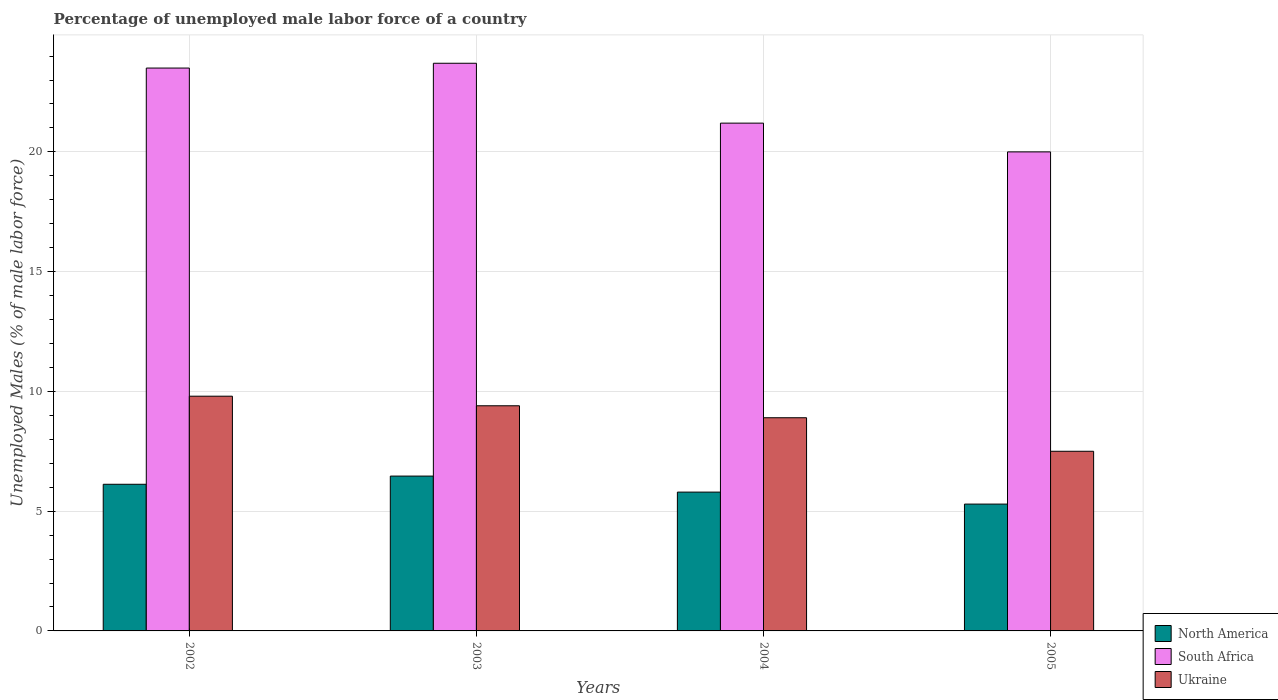How many different coloured bars are there?
Offer a very short reply. 3. How many groups of bars are there?
Keep it short and to the point. 4. What is the label of the 3rd group of bars from the left?
Your response must be concise. 2004. In how many cases, is the number of bars for a given year not equal to the number of legend labels?
Offer a very short reply. 0. What is the percentage of unemployed male labor force in North America in 2002?
Your answer should be compact. 6.12. Across all years, what is the maximum percentage of unemployed male labor force in North America?
Give a very brief answer. 6.46. Across all years, what is the minimum percentage of unemployed male labor force in North America?
Provide a short and direct response. 5.3. In which year was the percentage of unemployed male labor force in North America minimum?
Ensure brevity in your answer.  2005. What is the total percentage of unemployed male labor force in North America in the graph?
Your response must be concise. 23.68. What is the difference between the percentage of unemployed male labor force in North America in 2003 and that in 2004?
Your response must be concise. 0.67. What is the difference between the percentage of unemployed male labor force in South Africa in 2005 and the percentage of unemployed male labor force in North America in 2003?
Offer a terse response. 13.54. What is the average percentage of unemployed male labor force in South Africa per year?
Your answer should be very brief. 22.1. In the year 2002, what is the difference between the percentage of unemployed male labor force in Ukraine and percentage of unemployed male labor force in South Africa?
Your response must be concise. -13.7. What is the ratio of the percentage of unemployed male labor force in North America in 2004 to that in 2005?
Your answer should be compact. 1.09. What is the difference between the highest and the second highest percentage of unemployed male labor force in North America?
Ensure brevity in your answer.  0.34. What is the difference between the highest and the lowest percentage of unemployed male labor force in Ukraine?
Offer a very short reply. 2.3. In how many years, is the percentage of unemployed male labor force in Ukraine greater than the average percentage of unemployed male labor force in Ukraine taken over all years?
Your response must be concise. 2. Is the sum of the percentage of unemployed male labor force in North America in 2003 and 2005 greater than the maximum percentage of unemployed male labor force in South Africa across all years?
Offer a very short reply. No. What does the 2nd bar from the left in 2004 represents?
Ensure brevity in your answer.  South Africa. What does the 1st bar from the right in 2002 represents?
Make the answer very short. Ukraine. How many bars are there?
Offer a very short reply. 12. Are all the bars in the graph horizontal?
Offer a terse response. No. How many years are there in the graph?
Provide a succinct answer. 4. What is the difference between two consecutive major ticks on the Y-axis?
Offer a very short reply. 5. Are the values on the major ticks of Y-axis written in scientific E-notation?
Keep it short and to the point. No. Where does the legend appear in the graph?
Your answer should be compact. Bottom right. How many legend labels are there?
Offer a very short reply. 3. How are the legend labels stacked?
Your response must be concise. Vertical. What is the title of the graph?
Keep it short and to the point. Percentage of unemployed male labor force of a country. Does "Arab World" appear as one of the legend labels in the graph?
Ensure brevity in your answer.  No. What is the label or title of the X-axis?
Give a very brief answer. Years. What is the label or title of the Y-axis?
Give a very brief answer. Unemployed Males (% of male labor force). What is the Unemployed Males (% of male labor force) in North America in 2002?
Provide a short and direct response. 6.12. What is the Unemployed Males (% of male labor force) of Ukraine in 2002?
Offer a terse response. 9.8. What is the Unemployed Males (% of male labor force) of North America in 2003?
Ensure brevity in your answer.  6.46. What is the Unemployed Males (% of male labor force) in South Africa in 2003?
Make the answer very short. 23.7. What is the Unemployed Males (% of male labor force) in Ukraine in 2003?
Ensure brevity in your answer.  9.4. What is the Unemployed Males (% of male labor force) of North America in 2004?
Offer a terse response. 5.8. What is the Unemployed Males (% of male labor force) in South Africa in 2004?
Provide a short and direct response. 21.2. What is the Unemployed Males (% of male labor force) of Ukraine in 2004?
Provide a short and direct response. 8.9. What is the Unemployed Males (% of male labor force) of North America in 2005?
Your response must be concise. 5.3. What is the Unemployed Males (% of male labor force) in Ukraine in 2005?
Ensure brevity in your answer.  7.5. Across all years, what is the maximum Unemployed Males (% of male labor force) in North America?
Make the answer very short. 6.46. Across all years, what is the maximum Unemployed Males (% of male labor force) in South Africa?
Your answer should be very brief. 23.7. Across all years, what is the maximum Unemployed Males (% of male labor force) in Ukraine?
Ensure brevity in your answer.  9.8. Across all years, what is the minimum Unemployed Males (% of male labor force) in North America?
Provide a succinct answer. 5.3. Across all years, what is the minimum Unemployed Males (% of male labor force) of South Africa?
Make the answer very short. 20. Across all years, what is the minimum Unemployed Males (% of male labor force) in Ukraine?
Your response must be concise. 7.5. What is the total Unemployed Males (% of male labor force) in North America in the graph?
Make the answer very short. 23.68. What is the total Unemployed Males (% of male labor force) of South Africa in the graph?
Offer a terse response. 88.4. What is the total Unemployed Males (% of male labor force) of Ukraine in the graph?
Your answer should be very brief. 35.6. What is the difference between the Unemployed Males (% of male labor force) in North America in 2002 and that in 2003?
Offer a terse response. -0.34. What is the difference between the Unemployed Males (% of male labor force) of Ukraine in 2002 and that in 2003?
Offer a very short reply. 0.4. What is the difference between the Unemployed Males (% of male labor force) of North America in 2002 and that in 2004?
Keep it short and to the point. 0.33. What is the difference between the Unemployed Males (% of male labor force) of Ukraine in 2002 and that in 2004?
Ensure brevity in your answer.  0.9. What is the difference between the Unemployed Males (% of male labor force) of North America in 2002 and that in 2005?
Provide a short and direct response. 0.83. What is the difference between the Unemployed Males (% of male labor force) in South Africa in 2002 and that in 2005?
Provide a short and direct response. 3.5. What is the difference between the Unemployed Males (% of male labor force) in Ukraine in 2002 and that in 2005?
Ensure brevity in your answer.  2.3. What is the difference between the Unemployed Males (% of male labor force) of North America in 2003 and that in 2004?
Offer a very short reply. 0.67. What is the difference between the Unemployed Males (% of male labor force) of South Africa in 2003 and that in 2004?
Your answer should be very brief. 2.5. What is the difference between the Unemployed Males (% of male labor force) of North America in 2003 and that in 2005?
Provide a succinct answer. 1.17. What is the difference between the Unemployed Males (% of male labor force) of South Africa in 2003 and that in 2005?
Ensure brevity in your answer.  3.7. What is the difference between the Unemployed Males (% of male labor force) in North America in 2004 and that in 2005?
Your answer should be very brief. 0.5. What is the difference between the Unemployed Males (% of male labor force) in North America in 2002 and the Unemployed Males (% of male labor force) in South Africa in 2003?
Give a very brief answer. -17.58. What is the difference between the Unemployed Males (% of male labor force) in North America in 2002 and the Unemployed Males (% of male labor force) in Ukraine in 2003?
Provide a short and direct response. -3.28. What is the difference between the Unemployed Males (% of male labor force) in South Africa in 2002 and the Unemployed Males (% of male labor force) in Ukraine in 2003?
Make the answer very short. 14.1. What is the difference between the Unemployed Males (% of male labor force) in North America in 2002 and the Unemployed Males (% of male labor force) in South Africa in 2004?
Offer a terse response. -15.08. What is the difference between the Unemployed Males (% of male labor force) of North America in 2002 and the Unemployed Males (% of male labor force) of Ukraine in 2004?
Give a very brief answer. -2.78. What is the difference between the Unemployed Males (% of male labor force) of North America in 2002 and the Unemployed Males (% of male labor force) of South Africa in 2005?
Make the answer very short. -13.88. What is the difference between the Unemployed Males (% of male labor force) of North America in 2002 and the Unemployed Males (% of male labor force) of Ukraine in 2005?
Ensure brevity in your answer.  -1.38. What is the difference between the Unemployed Males (% of male labor force) of South Africa in 2002 and the Unemployed Males (% of male labor force) of Ukraine in 2005?
Provide a short and direct response. 16. What is the difference between the Unemployed Males (% of male labor force) in North America in 2003 and the Unemployed Males (% of male labor force) in South Africa in 2004?
Keep it short and to the point. -14.74. What is the difference between the Unemployed Males (% of male labor force) in North America in 2003 and the Unemployed Males (% of male labor force) in Ukraine in 2004?
Your answer should be compact. -2.44. What is the difference between the Unemployed Males (% of male labor force) of South Africa in 2003 and the Unemployed Males (% of male labor force) of Ukraine in 2004?
Your answer should be compact. 14.8. What is the difference between the Unemployed Males (% of male labor force) of North America in 2003 and the Unemployed Males (% of male labor force) of South Africa in 2005?
Provide a succinct answer. -13.54. What is the difference between the Unemployed Males (% of male labor force) in North America in 2003 and the Unemployed Males (% of male labor force) in Ukraine in 2005?
Give a very brief answer. -1.04. What is the difference between the Unemployed Males (% of male labor force) in South Africa in 2003 and the Unemployed Males (% of male labor force) in Ukraine in 2005?
Your response must be concise. 16.2. What is the difference between the Unemployed Males (% of male labor force) in North America in 2004 and the Unemployed Males (% of male labor force) in South Africa in 2005?
Make the answer very short. -14.2. What is the difference between the Unemployed Males (% of male labor force) of North America in 2004 and the Unemployed Males (% of male labor force) of Ukraine in 2005?
Keep it short and to the point. -1.7. What is the difference between the Unemployed Males (% of male labor force) of South Africa in 2004 and the Unemployed Males (% of male labor force) of Ukraine in 2005?
Offer a terse response. 13.7. What is the average Unemployed Males (% of male labor force) of North America per year?
Give a very brief answer. 5.92. What is the average Unemployed Males (% of male labor force) of South Africa per year?
Provide a short and direct response. 22.1. In the year 2002, what is the difference between the Unemployed Males (% of male labor force) in North America and Unemployed Males (% of male labor force) in South Africa?
Ensure brevity in your answer.  -17.38. In the year 2002, what is the difference between the Unemployed Males (% of male labor force) in North America and Unemployed Males (% of male labor force) in Ukraine?
Give a very brief answer. -3.68. In the year 2003, what is the difference between the Unemployed Males (% of male labor force) in North America and Unemployed Males (% of male labor force) in South Africa?
Provide a short and direct response. -17.24. In the year 2003, what is the difference between the Unemployed Males (% of male labor force) in North America and Unemployed Males (% of male labor force) in Ukraine?
Make the answer very short. -2.94. In the year 2003, what is the difference between the Unemployed Males (% of male labor force) of South Africa and Unemployed Males (% of male labor force) of Ukraine?
Your response must be concise. 14.3. In the year 2004, what is the difference between the Unemployed Males (% of male labor force) of North America and Unemployed Males (% of male labor force) of South Africa?
Keep it short and to the point. -15.4. In the year 2004, what is the difference between the Unemployed Males (% of male labor force) of North America and Unemployed Males (% of male labor force) of Ukraine?
Give a very brief answer. -3.1. In the year 2005, what is the difference between the Unemployed Males (% of male labor force) of North America and Unemployed Males (% of male labor force) of South Africa?
Your answer should be very brief. -14.7. In the year 2005, what is the difference between the Unemployed Males (% of male labor force) in North America and Unemployed Males (% of male labor force) in Ukraine?
Keep it short and to the point. -2.2. In the year 2005, what is the difference between the Unemployed Males (% of male labor force) of South Africa and Unemployed Males (% of male labor force) of Ukraine?
Make the answer very short. 12.5. What is the ratio of the Unemployed Males (% of male labor force) in North America in 2002 to that in 2003?
Provide a succinct answer. 0.95. What is the ratio of the Unemployed Males (% of male labor force) of South Africa in 2002 to that in 2003?
Keep it short and to the point. 0.99. What is the ratio of the Unemployed Males (% of male labor force) in Ukraine in 2002 to that in 2003?
Give a very brief answer. 1.04. What is the ratio of the Unemployed Males (% of male labor force) in North America in 2002 to that in 2004?
Provide a succinct answer. 1.06. What is the ratio of the Unemployed Males (% of male labor force) of South Africa in 2002 to that in 2004?
Ensure brevity in your answer.  1.11. What is the ratio of the Unemployed Males (% of male labor force) of Ukraine in 2002 to that in 2004?
Offer a terse response. 1.1. What is the ratio of the Unemployed Males (% of male labor force) of North America in 2002 to that in 2005?
Make the answer very short. 1.16. What is the ratio of the Unemployed Males (% of male labor force) in South Africa in 2002 to that in 2005?
Provide a short and direct response. 1.18. What is the ratio of the Unemployed Males (% of male labor force) in Ukraine in 2002 to that in 2005?
Your answer should be very brief. 1.31. What is the ratio of the Unemployed Males (% of male labor force) in North America in 2003 to that in 2004?
Offer a very short reply. 1.12. What is the ratio of the Unemployed Males (% of male labor force) in South Africa in 2003 to that in 2004?
Ensure brevity in your answer.  1.12. What is the ratio of the Unemployed Males (% of male labor force) in Ukraine in 2003 to that in 2004?
Your answer should be compact. 1.06. What is the ratio of the Unemployed Males (% of male labor force) in North America in 2003 to that in 2005?
Your response must be concise. 1.22. What is the ratio of the Unemployed Males (% of male labor force) in South Africa in 2003 to that in 2005?
Your response must be concise. 1.19. What is the ratio of the Unemployed Males (% of male labor force) in Ukraine in 2003 to that in 2005?
Ensure brevity in your answer.  1.25. What is the ratio of the Unemployed Males (% of male labor force) of North America in 2004 to that in 2005?
Offer a terse response. 1.09. What is the ratio of the Unemployed Males (% of male labor force) in South Africa in 2004 to that in 2005?
Make the answer very short. 1.06. What is the ratio of the Unemployed Males (% of male labor force) of Ukraine in 2004 to that in 2005?
Offer a terse response. 1.19. What is the difference between the highest and the second highest Unemployed Males (% of male labor force) of North America?
Your answer should be compact. 0.34. What is the difference between the highest and the second highest Unemployed Males (% of male labor force) of Ukraine?
Your response must be concise. 0.4. What is the difference between the highest and the lowest Unemployed Males (% of male labor force) in North America?
Your answer should be very brief. 1.17. What is the difference between the highest and the lowest Unemployed Males (% of male labor force) in South Africa?
Offer a very short reply. 3.7. What is the difference between the highest and the lowest Unemployed Males (% of male labor force) of Ukraine?
Offer a very short reply. 2.3. 